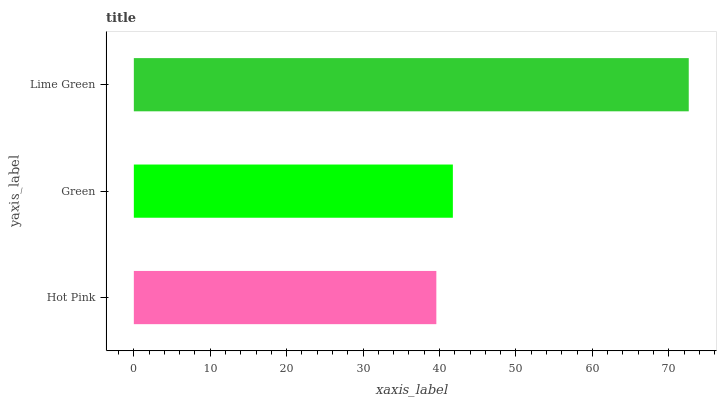Is Hot Pink the minimum?
Answer yes or no. Yes. Is Lime Green the maximum?
Answer yes or no. Yes. Is Green the minimum?
Answer yes or no. No. Is Green the maximum?
Answer yes or no. No. Is Green greater than Hot Pink?
Answer yes or no. Yes. Is Hot Pink less than Green?
Answer yes or no. Yes. Is Hot Pink greater than Green?
Answer yes or no. No. Is Green less than Hot Pink?
Answer yes or no. No. Is Green the high median?
Answer yes or no. Yes. Is Green the low median?
Answer yes or no. Yes. Is Hot Pink the high median?
Answer yes or no. No. Is Lime Green the low median?
Answer yes or no. No. 